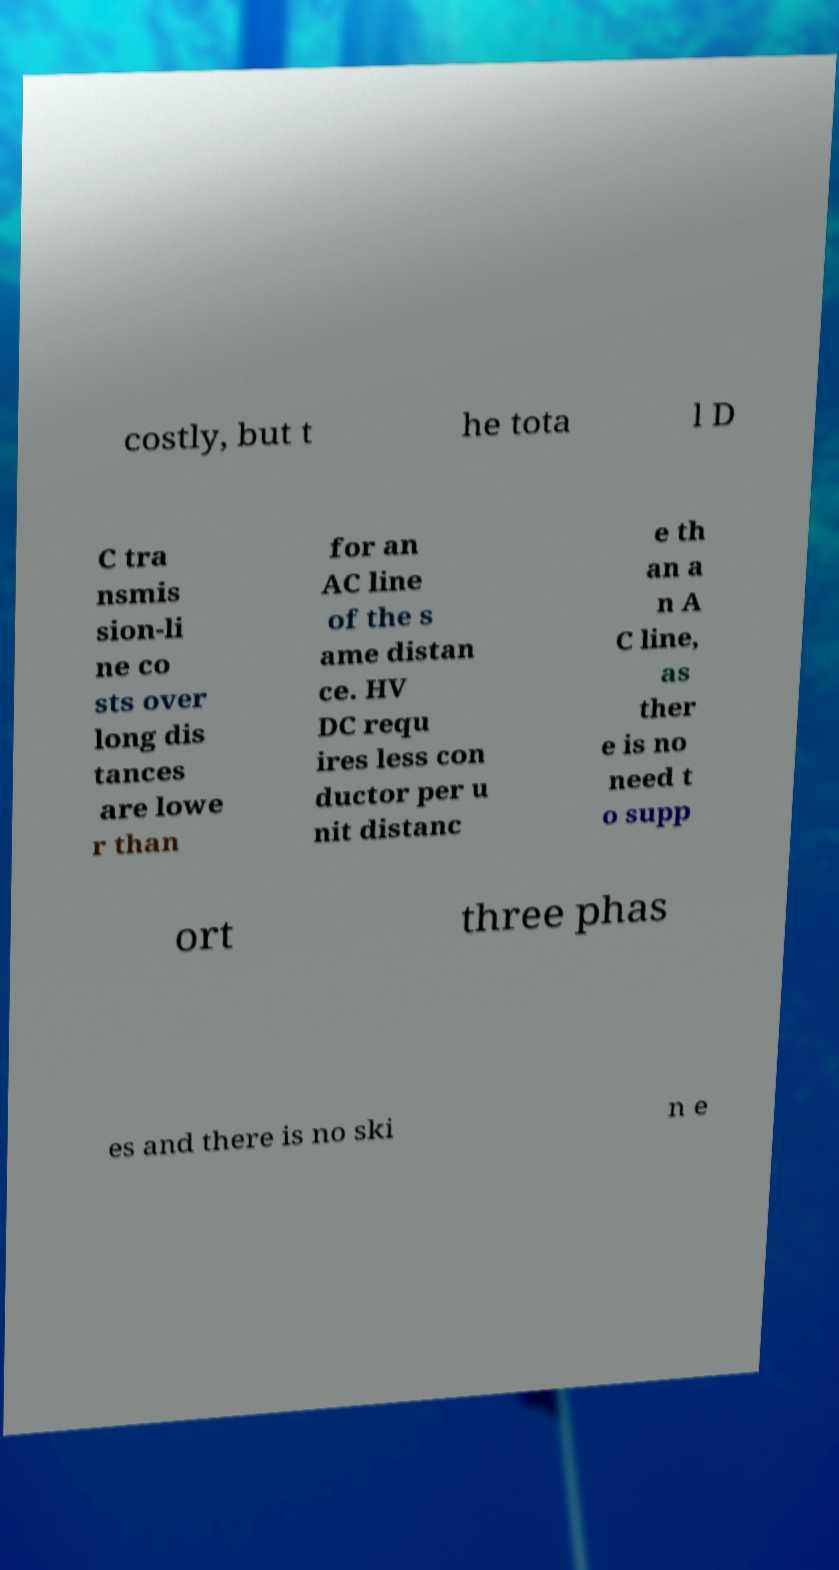Could you assist in decoding the text presented in this image and type it out clearly? costly, but t he tota l D C tra nsmis sion-li ne co sts over long dis tances are lowe r than for an AC line of the s ame distan ce. HV DC requ ires less con ductor per u nit distanc e th an a n A C line, as ther e is no need t o supp ort three phas es and there is no ski n e 